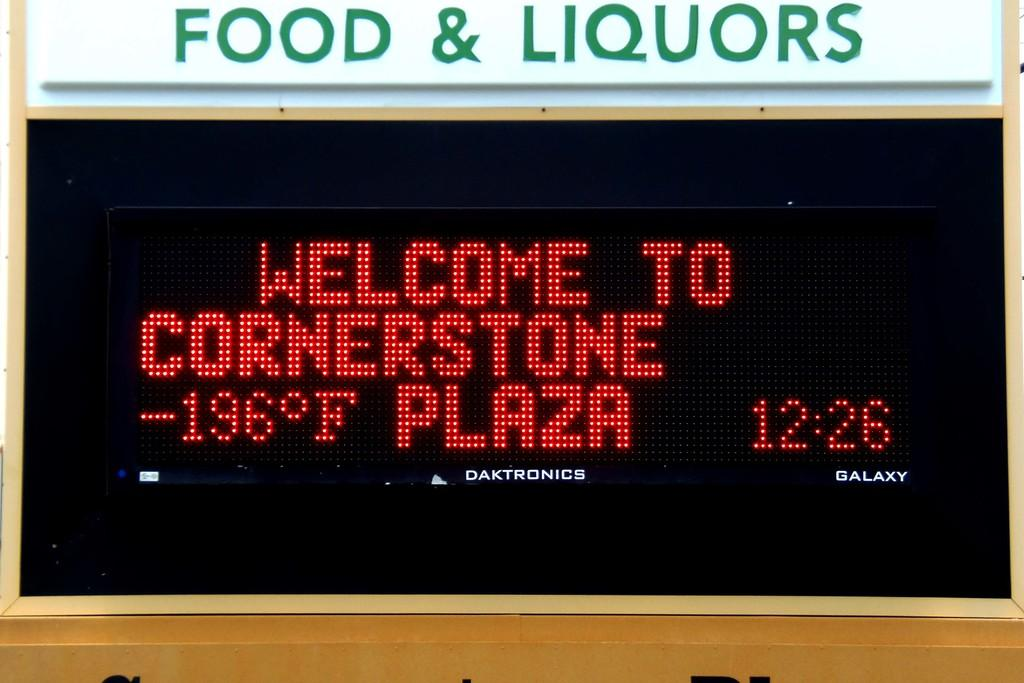<image>
Write a terse but informative summary of the picture. Cornerstone Plaza has a display sign underneath a sign for Food & Liquors. 